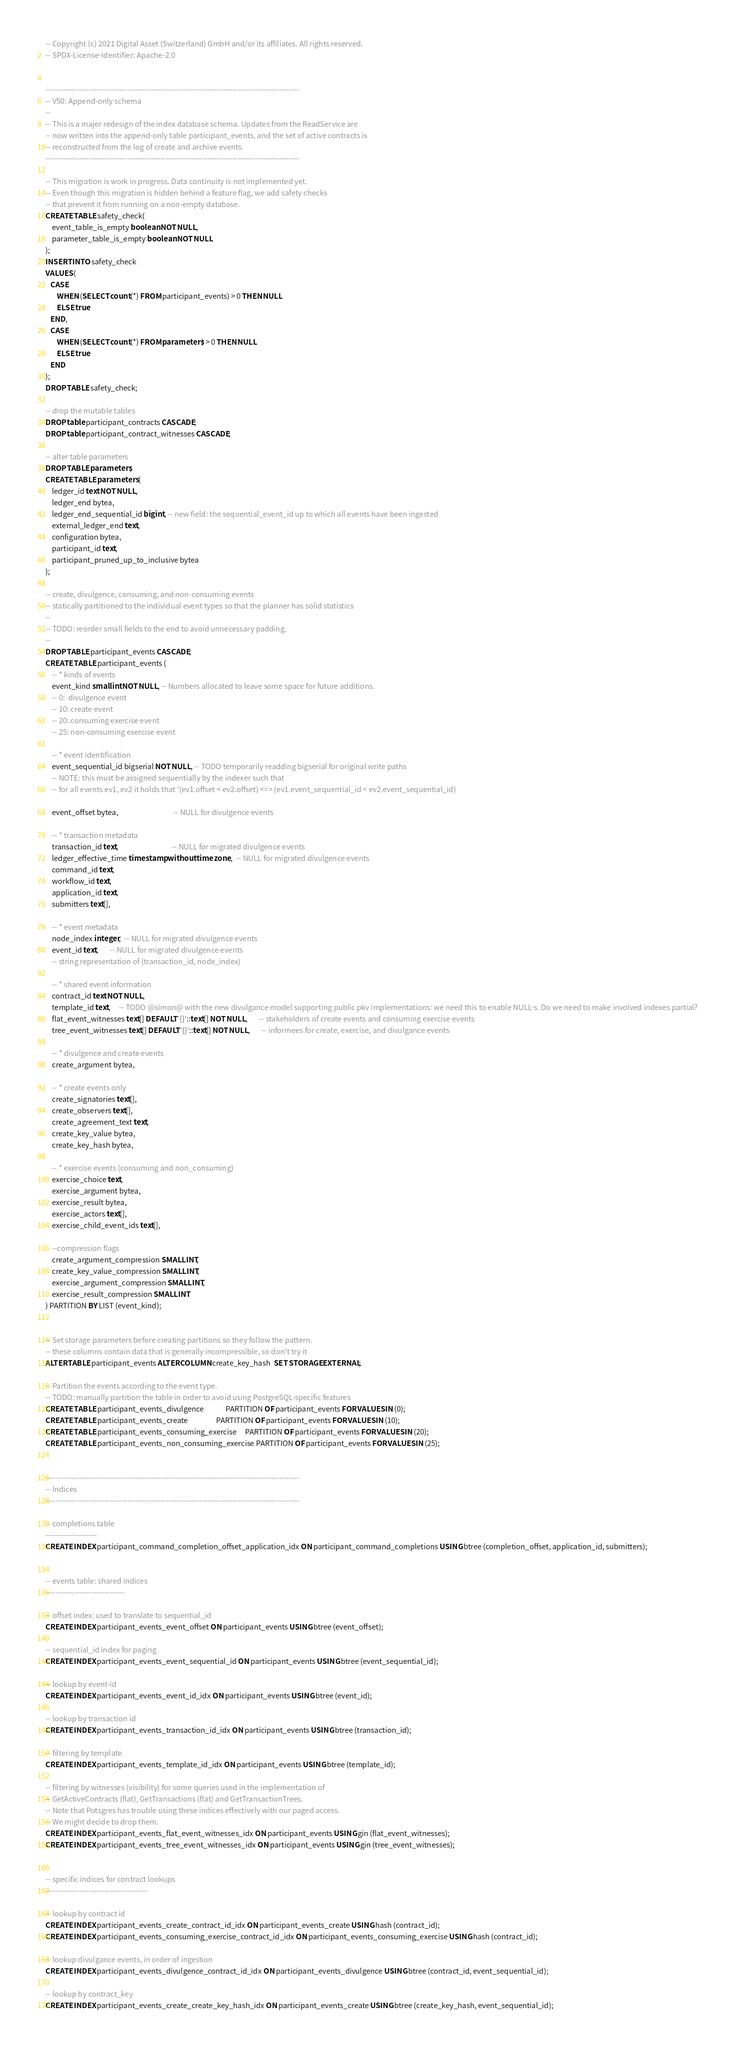Convert code to text. <code><loc_0><loc_0><loc_500><loc_500><_SQL_>-- Copyright (c) 2021 Digital Asset (Switzerland) GmbH and/or its affiliates. All rights reserved.
-- SPDX-License-Identifier: Apache-2.0


---------------------------------------------------------------------------------------------------
-- V50: Append-only schema
--
-- This is a major redesign of the index database schema. Updates from the ReadService are
-- now written into the append-only table participant_events, and the set of active contracts is
-- reconstructed from the log of create and archive events.
---------------------------------------------------------------------------------------------------

-- This migration is work in progress. Data continuity is not implemented yet.
-- Even though this migration is hidden behind a feature flag, we add safety checks
-- that prevent it from running on a non-empty database.
CREATE TABLE safety_check(
    event_table_is_empty boolean NOT NULL,
    parameter_table_is_empty boolean NOT NULL
);
INSERT INTO safety_check
VALUES (
   CASE
       WHEN (SELECT count(*) FROM participant_events) > 0 THEN NULL
       ELSE true
   END,
   CASE
       WHEN (SELECT count(*) FROM parameters) > 0 THEN NULL
       ELSE true
   END
);
DROP TABLE safety_check;

-- drop the mutable tables
DROP table participant_contracts CASCADE;
DROP table participant_contract_witnesses CASCADE;

-- alter table parameters
DROP TABLE parameters;
CREATE TABLE parameters (
    ledger_id text NOT NULL,
    ledger_end bytea,
    ledger_end_sequential_id bigint, -- new field: the sequential_event_id up to which all events have been ingested
    external_ledger_end text,
    configuration bytea,
    participant_id text,
    participant_pruned_up_to_inclusive bytea
);

-- create, divulgence, consuming, and non-consuming events
-- statically partitioned to the individual event types so that the planner has solid statistics
--
-- TODO: reorder small fields to the end to avoid unnecessary padding.
--
DROP TABLE participant_events CASCADE;
CREATE TABLE participant_events (
    -- * kinds of events
    event_kind smallint NOT NULL, -- Numbers allocated to leave some space for future additions.
    -- 0:  divulgence event
    -- 10: create event
    -- 20: consuming exercise event
    -- 25: non-consuming exercise event

    -- * event identification
    event_sequential_id bigserial NOT NULL, -- TODO temporarily readding bigserial for original write paths
    -- NOTE: this must be assigned sequentially by the indexer such that
    -- for all events ev1, ev2 it holds that '(ev1.offset < ev2.offset) <=> (ev1.event_sequential_id < ev2.event_sequential_id)

    event_offset bytea,                                 -- NULL for divulgence events

    -- * transaction metadata
    transaction_id text,                                -- NULL for migrated divulgence events
    ledger_effective_time timestamp without time zone,  -- NULL for migrated divulgence events
    command_id text,
    workflow_id text,
    application_id text,
    submitters text[],

    -- * event metadata
    node_index integer,  -- NULL for migrated divulgence events
    event_id text,       -- NULL for migrated divulgence events
    -- string representation of (transaction_id, node_index)

    -- * shared event information
    contract_id text NOT NULL,
    template_id text,     -- TODO @simon@ with the new divulgance model supporting public pkv implementations: we need this to enable NULL-s. Do we need to make involved indexes partial?
    flat_event_witnesses text[] DEFAULT '{}'::text[] NOT NULL,       -- stakeholders of create events and consuming exercise events
    tree_event_witnesses text[] DEFAULT '{}'::text[] NOT NULL,       -- informees for create, exercise, and divulgance events

    -- * divulgence and create events
    create_argument bytea,

    -- * create events only
    create_signatories text[],
    create_observers text[],
    create_agreement_text text,
    create_key_value bytea,
    create_key_hash bytea,

    -- * exercise events (consuming and non_consuming)
    exercise_choice text,
    exercise_argument bytea,
    exercise_result bytea,
    exercise_actors text[],
    exercise_child_event_ids text[],

    --compression flags
    create_argument_compression SMALLINT,
    create_key_value_compression SMALLINT,
    exercise_argument_compression SMALLINT,
    exercise_result_compression SMALLINT
) PARTITION BY LIST (event_kind);


-- Set storage parameters before creating partitions so they follow the pattern.
-- these columns contain data that is generally incompressible, so don't try it
ALTER TABLE participant_events ALTER COLUMN create_key_hash  SET STORAGE EXTERNAL;

-- Partition the events according to the event type.
-- TODO: manually partition the table in order to avoid using PostgreSQL-specific features
CREATE TABLE participant_events_divulgence             PARTITION OF participant_events FOR VALUES IN (0);
CREATE TABLE participant_events_create                 PARTITION OF participant_events FOR VALUES IN (10);
CREATE TABLE participant_events_consuming_exercise     PARTITION OF participant_events FOR VALUES IN (20);
CREATE TABLE participant_events_non_consuming_exercise PARTITION OF participant_events FOR VALUES IN (25);


---------------------------------------------------------------------------------------------------
-- Indices
---------------------------------------------------------------------------------------------------

-- completions table
--------------------
CREATE INDEX participant_command_completion_offset_application_idx ON participant_command_completions USING btree (completion_offset, application_id, submitters);


-- events table: shared indices
-------------------------------

-- offset index: used to translate to sequential_id
CREATE INDEX participant_events_event_offset ON participant_events USING btree (event_offset);

-- sequential_id index for paging
CREATE INDEX participant_events_event_sequential_id ON participant_events USING btree (event_sequential_id);

-- lookup by event-id
CREATE INDEX participant_events_event_id_idx ON participant_events USING btree (event_id);

-- lookup by transaction id
CREATE INDEX participant_events_transaction_id_idx ON participant_events USING btree (transaction_id);

-- filtering by template
CREATE INDEX participant_events_template_id_idx ON participant_events USING btree (template_id);

-- filtering by witnesses (visibility) for some queries used in the implementation of
-- GetActiveContracts (flat), GetTransactions (flat) and GetTransactionTrees.
-- Note that Potsgres has trouble using these indices effectively with our paged access.
-- We might decide to drop them.
CREATE INDEX participant_events_flat_event_witnesses_idx ON participant_events USING gin (flat_event_witnesses);
CREATE INDEX participant_events_tree_event_witnesses_idx ON participant_events USING gin (tree_event_witnesses);


-- specific indices for contract lookups
----------------------------------------

-- lookup by contract id
CREATE INDEX participant_events_create_contract_id_idx ON participant_events_create USING hash (contract_id);
CREATE INDEX participant_events_consuming_exercise_contract_id_idx ON participant_events_consuming_exercise USING hash (contract_id);

-- lookup divulgance events, in order of ingestion
CREATE INDEX participant_events_divulgence_contract_id_idx ON participant_events_divulgence USING btree (contract_id, event_sequential_id);

-- lookup by contract_key
CREATE INDEX participant_events_create_create_key_hash_idx ON participant_events_create USING btree (create_key_hash, event_sequential_id);
</code> 